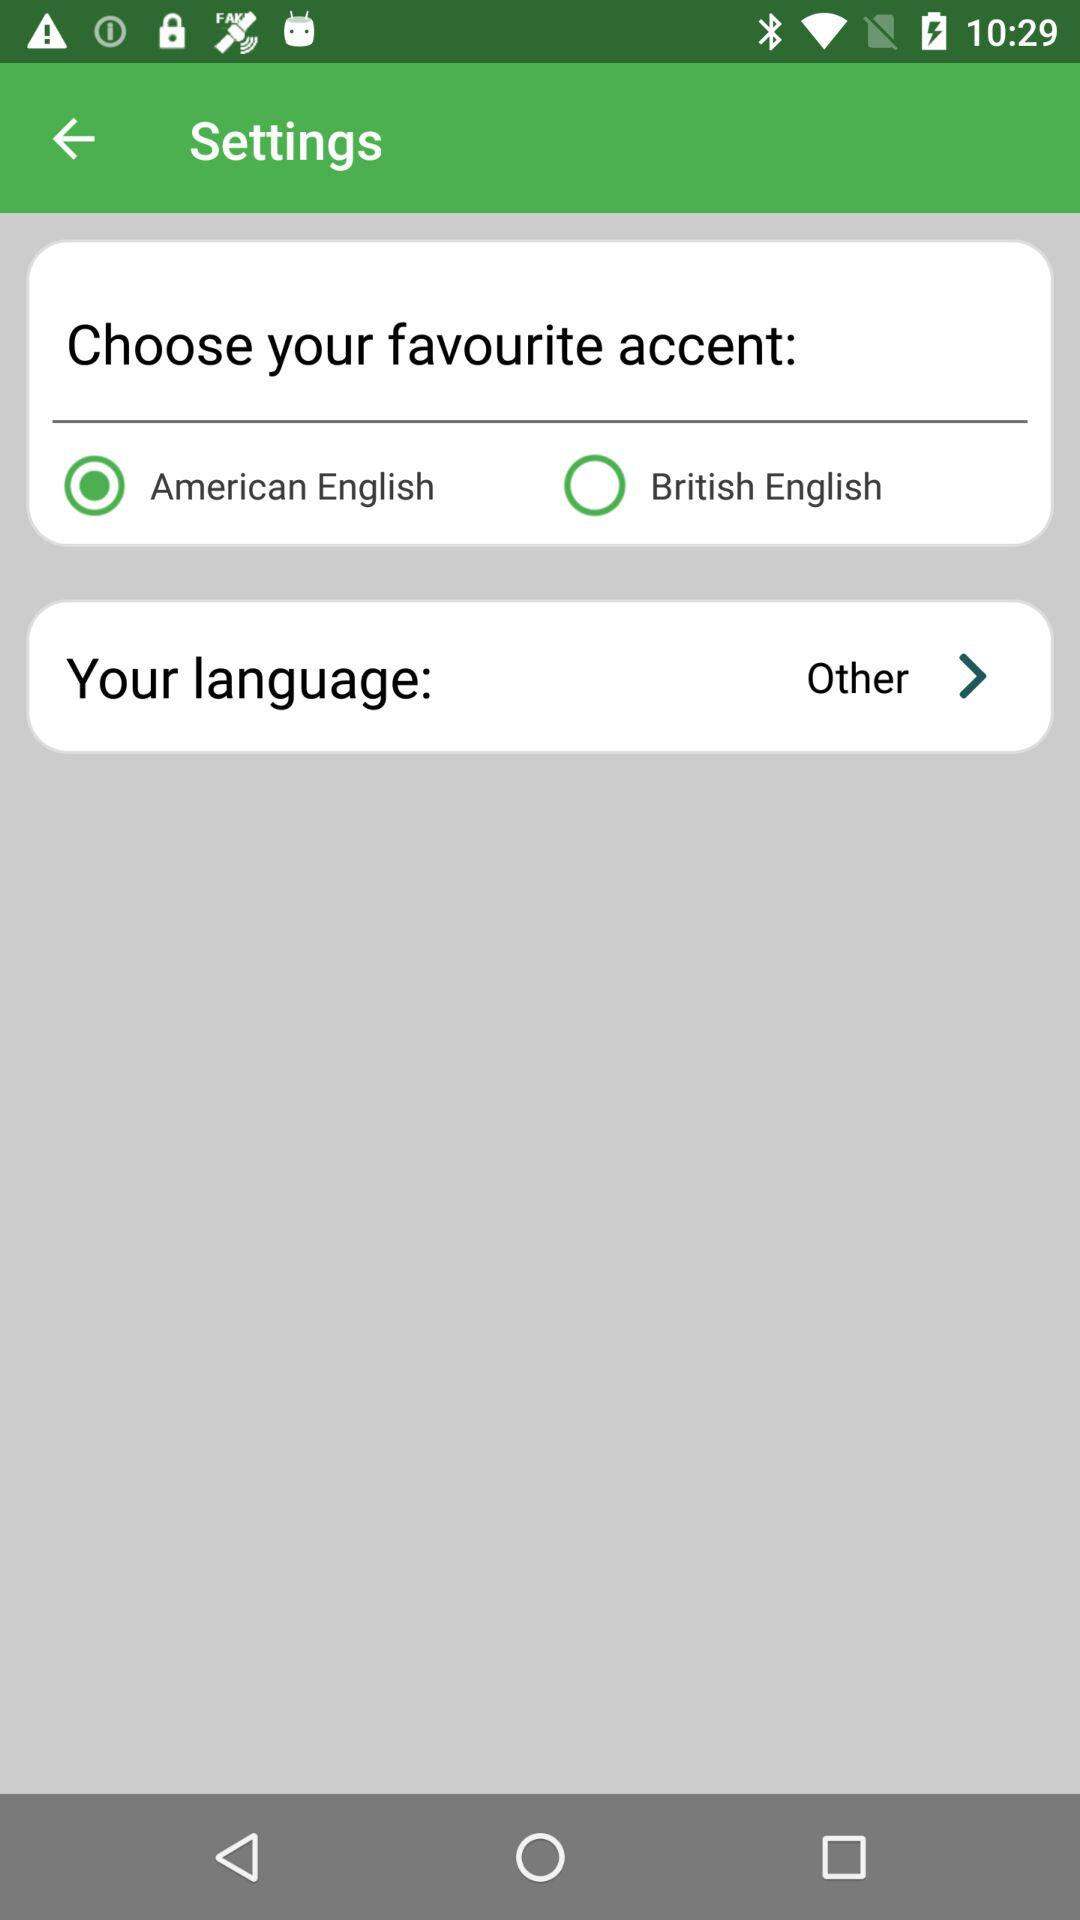What is the selected radio button for favorite accent? The selected radio button for favorite accent is "American English". 